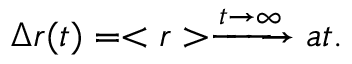<formula> <loc_0><loc_0><loc_500><loc_500>\Delta r ( t ) = < r > \xrightarrow { t \rightarrow \infty } a t .</formula> 